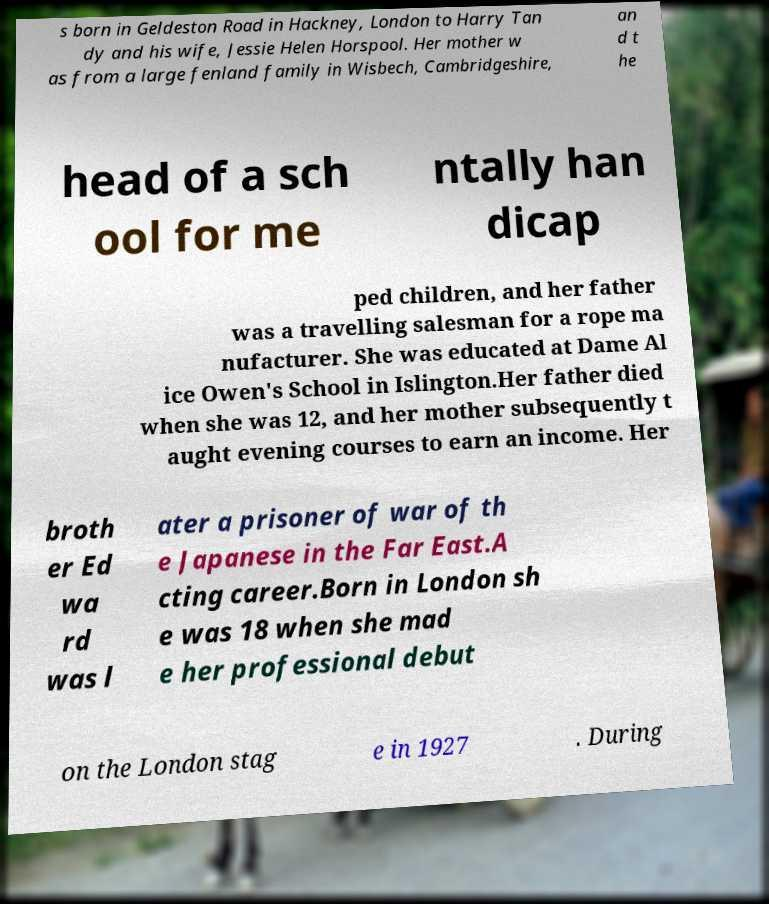I need the written content from this picture converted into text. Can you do that? s born in Geldeston Road in Hackney, London to Harry Tan dy and his wife, Jessie Helen Horspool. Her mother w as from a large fenland family in Wisbech, Cambridgeshire, an d t he head of a sch ool for me ntally han dicap ped children, and her father was a travelling salesman for a rope ma nufacturer. She was educated at Dame Al ice Owen's School in Islington.Her father died when she was 12, and her mother subsequently t aught evening courses to earn an income. Her broth er Ed wa rd was l ater a prisoner of war of th e Japanese in the Far East.A cting career.Born in London sh e was 18 when she mad e her professional debut on the London stag e in 1927 . During 